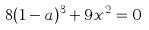<formula> <loc_0><loc_0><loc_500><loc_500>8 ( 1 - a ) ^ { 3 } + 9 x ^ { 2 } = 0</formula> 